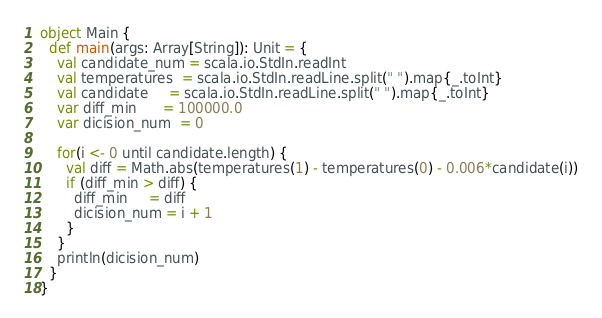Convert code to text. <code><loc_0><loc_0><loc_500><loc_500><_Scala_>object Main {
  def main(args: Array[String]): Unit = {
    val candidate_num = scala.io.StdIn.readInt
    val temperatures  = scala.io.StdIn.readLine.split(" ").map{_.toInt}
    val candidate     = scala.io.StdIn.readLine.split(" ").map{_.toInt}
    var diff_min      = 100000.0
    var dicision_num  = 0

    for(i <- 0 until candidate.length) {
      val diff = Math.abs(temperatures(1) - temperatures(0) - 0.006*candidate(i))
      if (diff_min > diff) {
        diff_min     = diff
        dicision_num = i + 1
      }
    }
    println(dicision_num)
  }
}</code> 